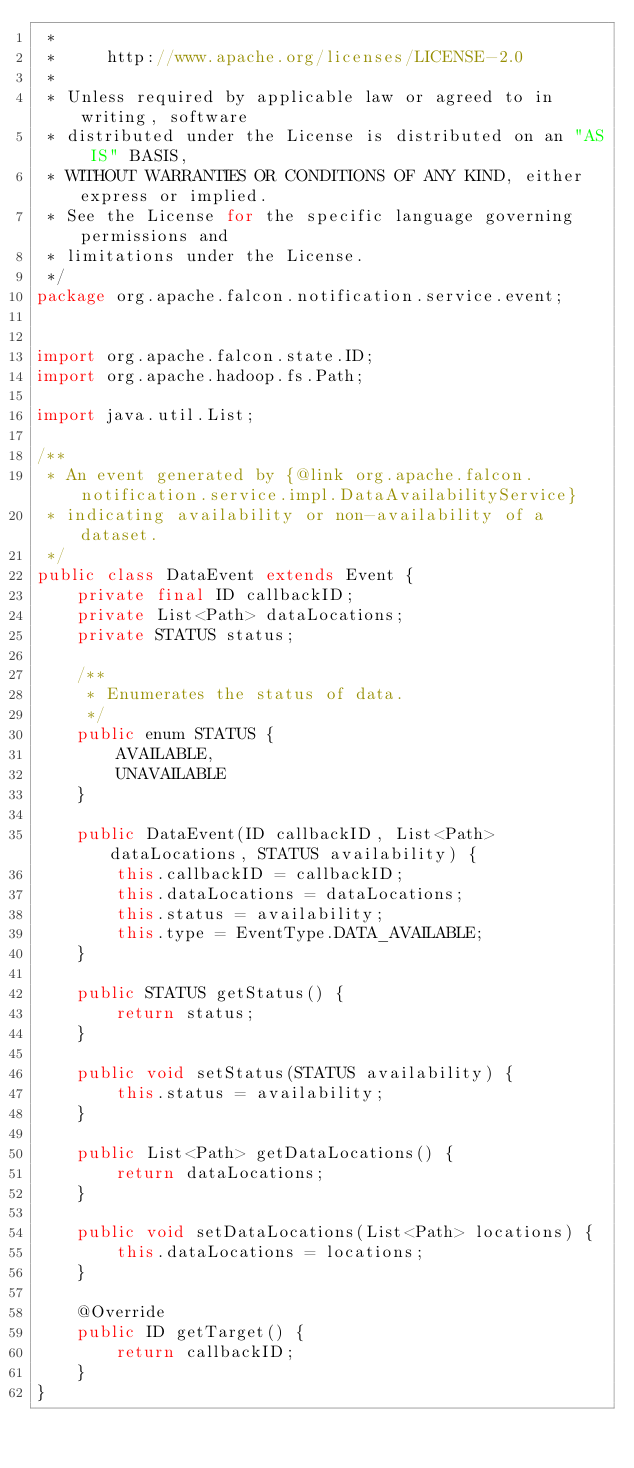<code> <loc_0><loc_0><loc_500><loc_500><_Java_> *
 *     http://www.apache.org/licenses/LICENSE-2.0
 *
 * Unless required by applicable law or agreed to in writing, software
 * distributed under the License is distributed on an "AS IS" BASIS,
 * WITHOUT WARRANTIES OR CONDITIONS OF ANY KIND, either express or implied.
 * See the License for the specific language governing permissions and
 * limitations under the License.
 */
package org.apache.falcon.notification.service.event;


import org.apache.falcon.state.ID;
import org.apache.hadoop.fs.Path;

import java.util.List;

/**
 * An event generated by {@link org.apache.falcon.notification.service.impl.DataAvailabilityService}
 * indicating availability or non-availability of a dataset.
 */
public class DataEvent extends Event {
    private final ID callbackID;
    private List<Path> dataLocations;
    private STATUS status;

    /**
     * Enumerates the status of data.
     */
    public enum STATUS {
        AVAILABLE,
        UNAVAILABLE
    }

    public DataEvent(ID callbackID, List<Path> dataLocations, STATUS availability) {
        this.callbackID = callbackID;
        this.dataLocations = dataLocations;
        this.status = availability;
        this.type = EventType.DATA_AVAILABLE;
    }

    public STATUS getStatus() {
        return status;
    }

    public void setStatus(STATUS availability) {
        this.status = availability;
    }

    public List<Path> getDataLocations() {
        return dataLocations;
    }

    public void setDataLocations(List<Path> locations) {
        this.dataLocations = locations;
    }

    @Override
    public ID getTarget() {
        return callbackID;
    }
}
</code> 